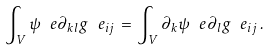Convert formula to latex. <formula><loc_0><loc_0><loc_500><loc_500>\int _ { V } \psi ^ { \ } e \partial _ { k l } g ^ { \ } e _ { i j } \, = \, \int _ { V } \partial _ { k } \psi ^ { \ } e \partial _ { l } g ^ { \ } e _ { i j } \, .</formula> 